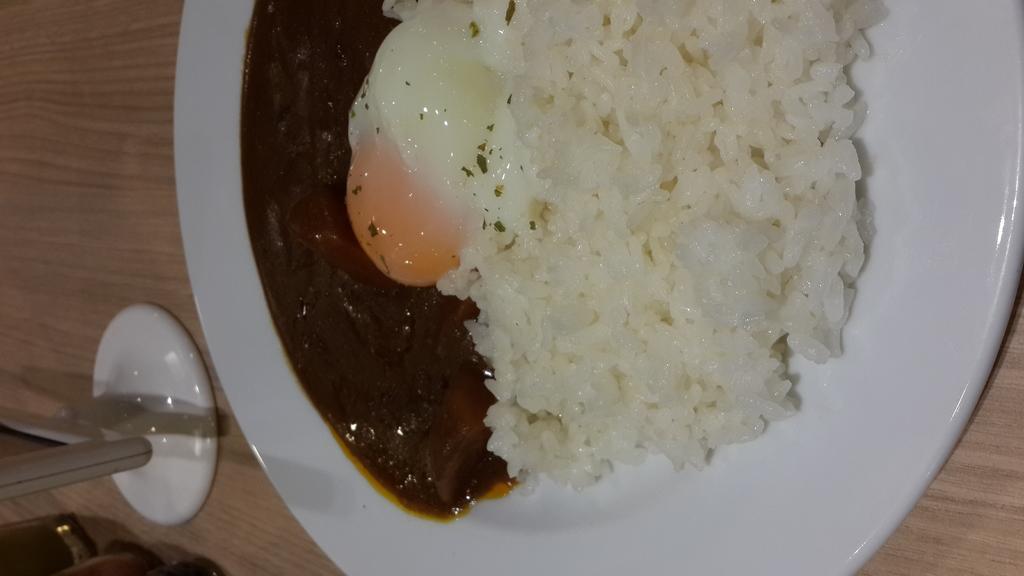Describe this image in one or two sentences. In this image there is a plate on the table. Left bottom there are few objects on the table. On the plate where is rice and some food are on it. 